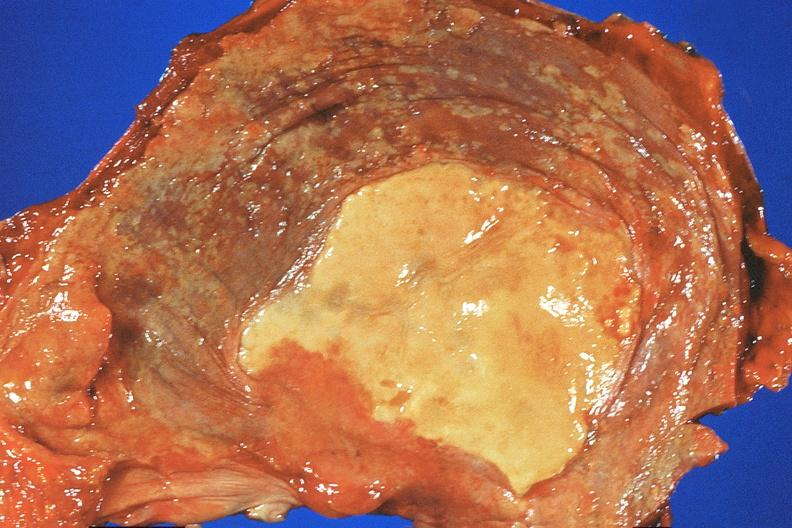does this image show diaphragm, asbestosis and mesothelioma?
Answer the question using a single word or phrase. Yes 